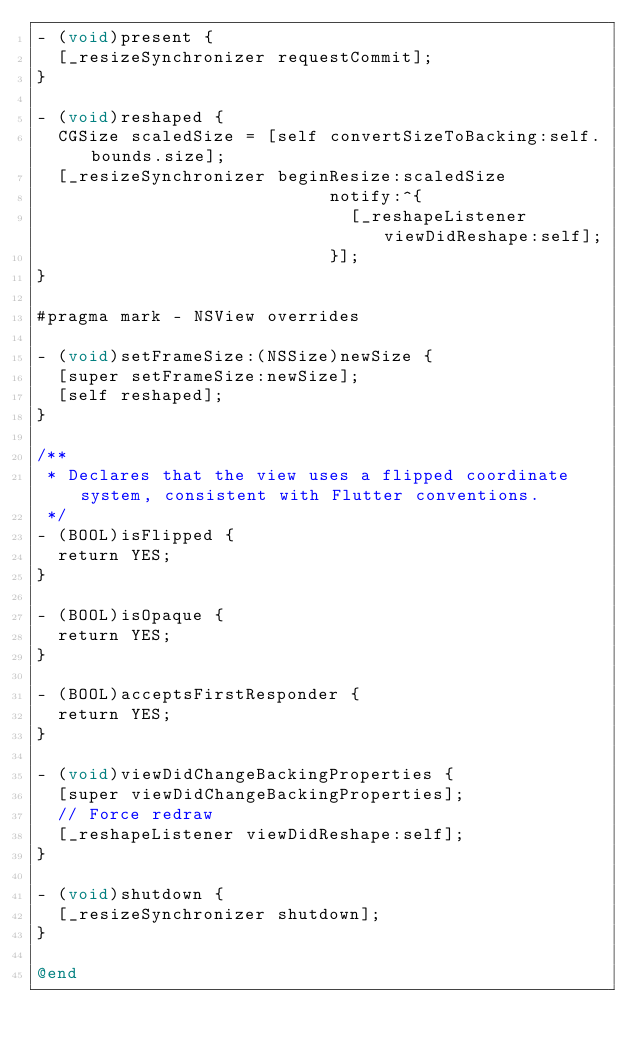<code> <loc_0><loc_0><loc_500><loc_500><_ObjectiveC_>- (void)present {
  [_resizeSynchronizer requestCommit];
}

- (void)reshaped {
  CGSize scaledSize = [self convertSizeToBacking:self.bounds.size];
  [_resizeSynchronizer beginResize:scaledSize
                            notify:^{
                              [_reshapeListener viewDidReshape:self];
                            }];
}

#pragma mark - NSView overrides

- (void)setFrameSize:(NSSize)newSize {
  [super setFrameSize:newSize];
  [self reshaped];
}

/**
 * Declares that the view uses a flipped coordinate system, consistent with Flutter conventions.
 */
- (BOOL)isFlipped {
  return YES;
}

- (BOOL)isOpaque {
  return YES;
}

- (BOOL)acceptsFirstResponder {
  return YES;
}

- (void)viewDidChangeBackingProperties {
  [super viewDidChangeBackingProperties];
  // Force redraw
  [_reshapeListener viewDidReshape:self];
}

- (void)shutdown {
  [_resizeSynchronizer shutdown];
}

@end
</code> 